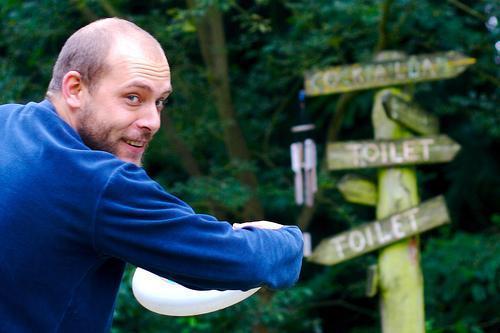How many people are in this photo?
Give a very brief answer. 1. How many signs visible say "TOILET"?
Give a very brief answer. 2. 